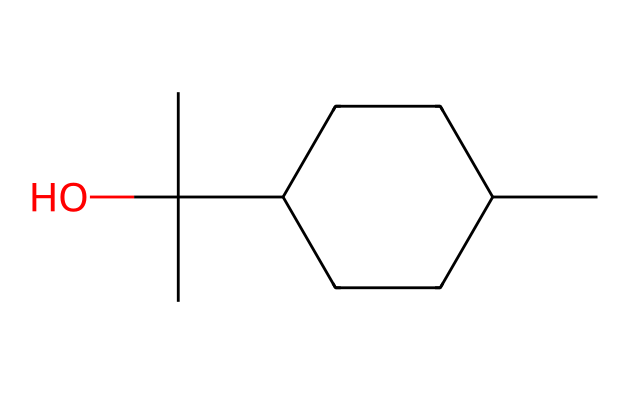What is the name of this chemical? The SMILES representation "CC1CCC(C(C)(C)O)CC1" corresponds to menthol, which is a cyclic alcohol with a distinctive minty aroma.
Answer: menthol How many carbon atoms are in menthol? By analyzing the SMILES, there are a total of 10 carbon atoms represented in the structure (CC - two, C1 - marks the start of a cycle, and there are additional Cs connected in the ring).
Answer: 10 What type of functional group is present in menthol? The presence of the hydroxyl group (-OH) in the structure indicates that it is an alcohol. This is also confirmed by the additional representation of oxygen in the SMILES.
Answer: alcohol How many hydrogen atoms are attached to menthol? Based on the structure and accounting for the carbons' tetravalency and the presence of one hydroxyl group, there are 22 hydrogen atoms.
Answer: 22 What is the cycloalkane ring structure characteristic of menthol? The structure includes a six-membered carbon ring, indicated by the cyclic notation (C1) in the SMILES, which is typical for cycloalkanes. This structure gives menthol its unique properties.
Answer: six-membered ring What type of molecule is menthol classified as? Menthol is classified as a cyclic monoterpene alcohol, a specific category under cyclic compounds, which points to its unique structure and properties.
Answer: cyclic monoterpene alcohol Is menthol chiral? The presence of a carbon atom with four different substituents (the carbon attached to the hydroxyl group and three others) indicates that menthol is chiral, which can lead to different enantiomers.
Answer: chiral 